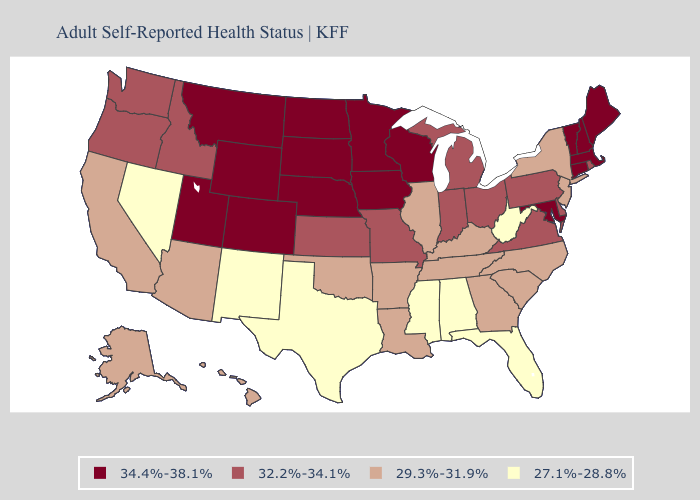Does Minnesota have the same value as New Jersey?
Give a very brief answer. No. Name the states that have a value in the range 29.3%-31.9%?
Answer briefly. Alaska, Arizona, Arkansas, California, Georgia, Hawaii, Illinois, Kentucky, Louisiana, New Jersey, New York, North Carolina, Oklahoma, South Carolina, Tennessee. What is the value of Utah?
Concise answer only. 34.4%-38.1%. Among the states that border Maryland , which have the highest value?
Quick response, please. Delaware, Pennsylvania, Virginia. What is the highest value in the USA?
Quick response, please. 34.4%-38.1%. Name the states that have a value in the range 29.3%-31.9%?
Quick response, please. Alaska, Arizona, Arkansas, California, Georgia, Hawaii, Illinois, Kentucky, Louisiana, New Jersey, New York, North Carolina, Oklahoma, South Carolina, Tennessee. What is the value of New Mexico?
Write a very short answer. 27.1%-28.8%. What is the lowest value in the USA?
Write a very short answer. 27.1%-28.8%. Does the first symbol in the legend represent the smallest category?
Concise answer only. No. What is the value of Rhode Island?
Concise answer only. 32.2%-34.1%. Which states have the lowest value in the MidWest?
Quick response, please. Illinois. Name the states that have a value in the range 32.2%-34.1%?
Give a very brief answer. Delaware, Idaho, Indiana, Kansas, Michigan, Missouri, Ohio, Oregon, Pennsylvania, Rhode Island, Virginia, Washington. Which states have the lowest value in the Northeast?
Answer briefly. New Jersey, New York. Name the states that have a value in the range 34.4%-38.1%?
Give a very brief answer. Colorado, Connecticut, Iowa, Maine, Maryland, Massachusetts, Minnesota, Montana, Nebraska, New Hampshire, North Dakota, South Dakota, Utah, Vermont, Wisconsin, Wyoming. What is the value of Arizona?
Short answer required. 29.3%-31.9%. 